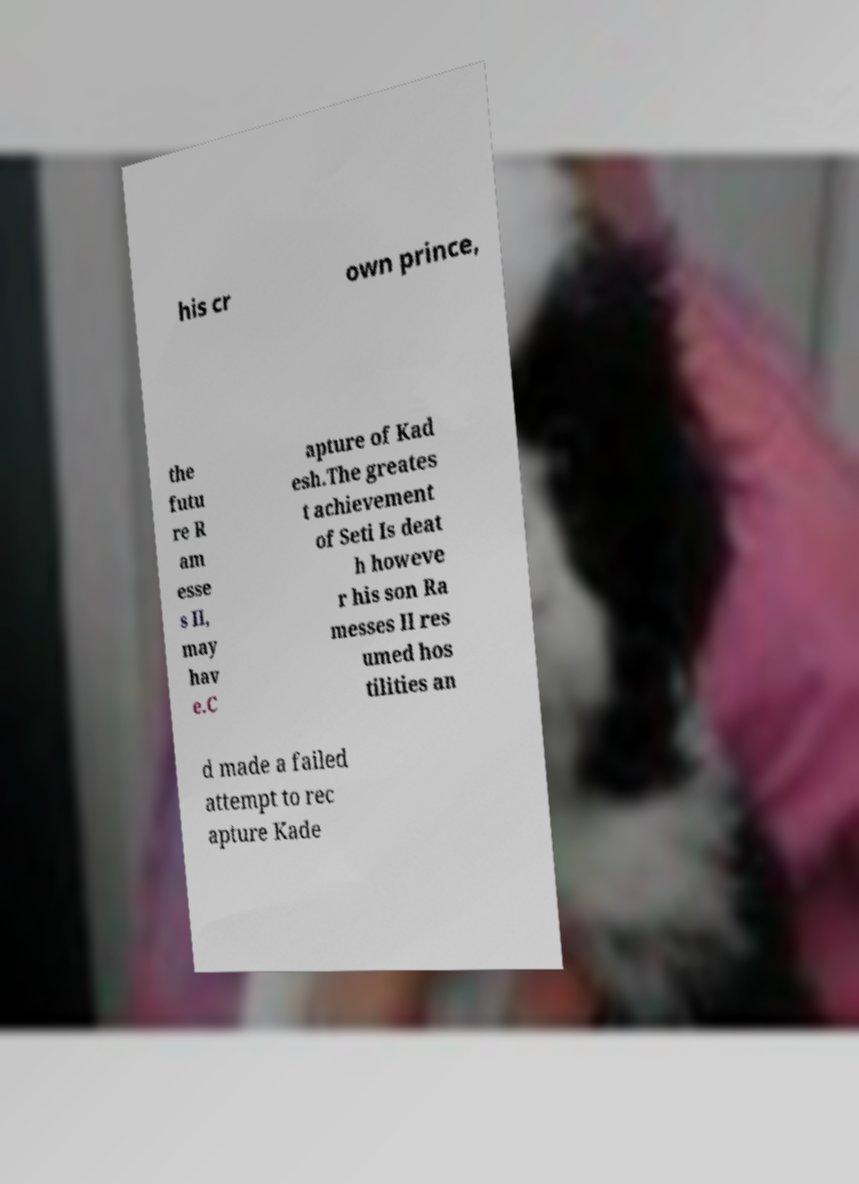For documentation purposes, I need the text within this image transcribed. Could you provide that? his cr own prince, the futu re R am esse s II, may hav e.C apture of Kad esh.The greates t achievement of Seti Is deat h howeve r his son Ra messes II res umed hos tilities an d made a failed attempt to rec apture Kade 